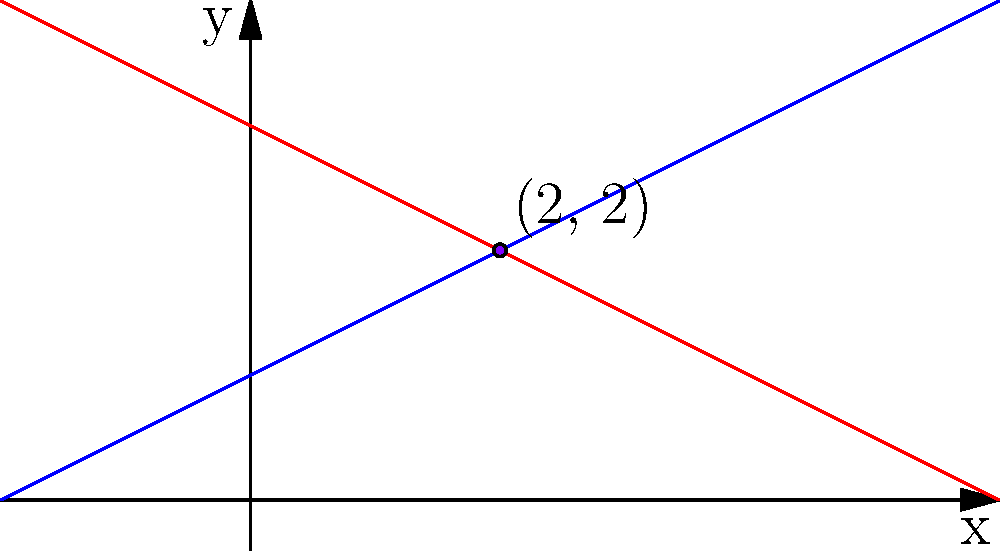In a debate on a pressing social issue, two conflicting viewpoints are represented by the lines $y = 0.5x + 1$ (traditional viewpoint) and $y = -0.5x + 3$ (progressive viewpoint). At what point do these viewpoints intersect, potentially representing a compromise? What is the significance of this point in the context of social change? To find the intersection point of the two lines, we need to solve the system of equations:

1) $y = 0.5x + 1$ (traditional viewpoint)
2) $y = -0.5x + 3$ (progressive viewpoint)

At the intersection point, the y-values are equal, so we can set the right sides of the equations equal to each other:

3) $0.5x + 1 = -0.5x + 3$

Now, let's solve for x:

4) $0.5x + 0.5x = 3 - 1$
5) $x = 2$

To find the y-coordinate, we can substitute x = 2 into either of the original equations. Let's use the first one:

6) $y = 0.5(2) + 1 = 2$

Therefore, the intersection point is (2, 2).

In the context of social change, this point represents a potential compromise between traditional and progressive viewpoints. It suggests that there might be a middle ground where both sides can find some agreement. For someone hesitant to act on social issues, this intersection point could be seen as a more moderate approach to addressing the problem, potentially making it easier to engage with the issue without fully committing to either extreme viewpoint.
Answer: (2, 2); represents a potential compromise between conflicting viewpoints on a social issue 